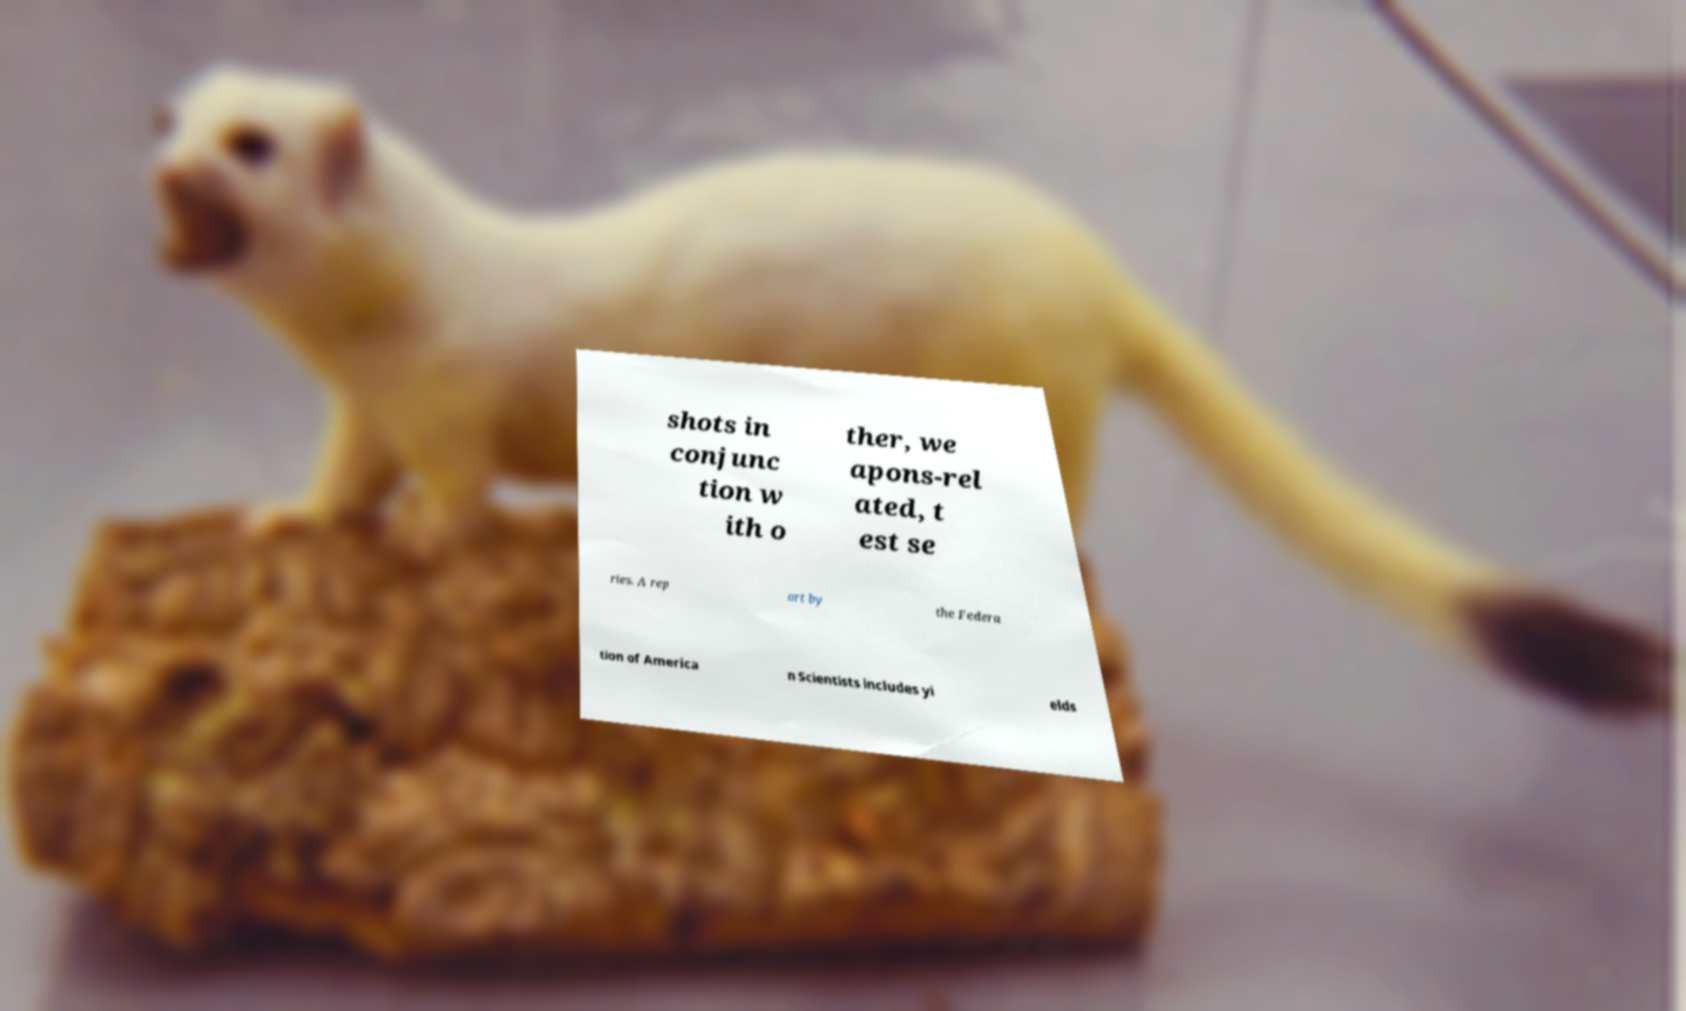Can you accurately transcribe the text from the provided image for me? shots in conjunc tion w ith o ther, we apons-rel ated, t est se ries. A rep ort by the Federa tion of America n Scientists includes yi elds 